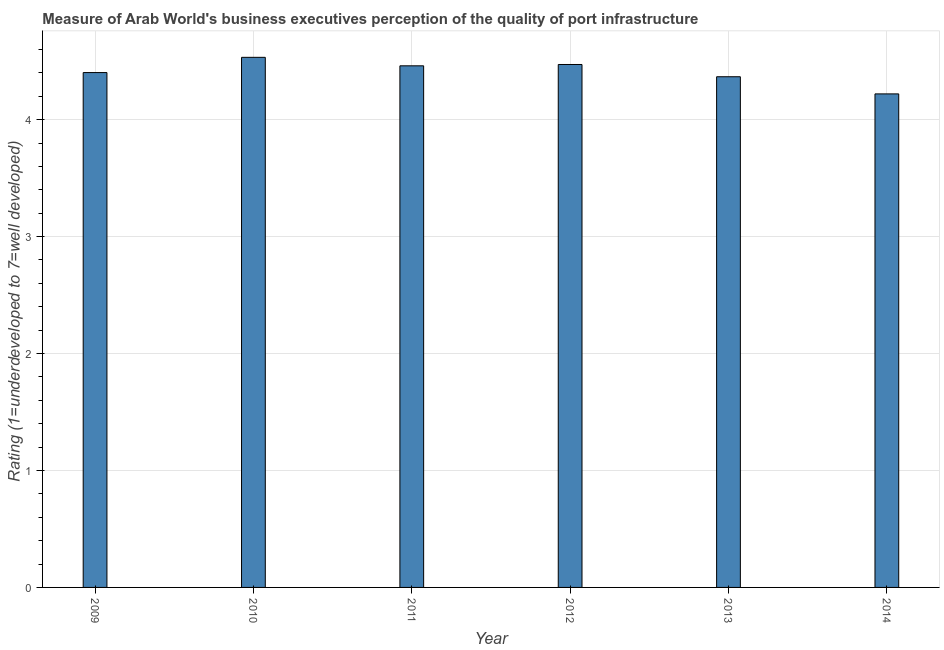Does the graph contain grids?
Offer a terse response. Yes. What is the title of the graph?
Give a very brief answer. Measure of Arab World's business executives perception of the quality of port infrastructure. What is the label or title of the Y-axis?
Offer a terse response. Rating (1=underdeveloped to 7=well developed) . What is the rating measuring quality of port infrastructure in 2010?
Ensure brevity in your answer.  4.53. Across all years, what is the maximum rating measuring quality of port infrastructure?
Give a very brief answer. 4.53. Across all years, what is the minimum rating measuring quality of port infrastructure?
Offer a terse response. 4.22. What is the sum of the rating measuring quality of port infrastructure?
Offer a terse response. 26.45. What is the difference between the rating measuring quality of port infrastructure in 2013 and 2014?
Provide a short and direct response. 0.15. What is the average rating measuring quality of port infrastructure per year?
Provide a succinct answer. 4.41. What is the median rating measuring quality of port infrastructure?
Offer a very short reply. 4.43. In how many years, is the rating measuring quality of port infrastructure greater than 0.8 ?
Give a very brief answer. 6. Is the difference between the rating measuring quality of port infrastructure in 2012 and 2014 greater than the difference between any two years?
Keep it short and to the point. No. What is the difference between the highest and the second highest rating measuring quality of port infrastructure?
Make the answer very short. 0.06. What is the difference between the highest and the lowest rating measuring quality of port infrastructure?
Your answer should be very brief. 0.31. In how many years, is the rating measuring quality of port infrastructure greater than the average rating measuring quality of port infrastructure taken over all years?
Offer a very short reply. 3. How many bars are there?
Offer a very short reply. 6. How many years are there in the graph?
Give a very brief answer. 6. Are the values on the major ticks of Y-axis written in scientific E-notation?
Give a very brief answer. No. What is the Rating (1=underdeveloped to 7=well developed)  of 2009?
Your answer should be compact. 4.4. What is the Rating (1=underdeveloped to 7=well developed)  in 2010?
Your answer should be very brief. 4.53. What is the Rating (1=underdeveloped to 7=well developed)  of 2011?
Your response must be concise. 4.46. What is the Rating (1=underdeveloped to 7=well developed)  of 2012?
Your answer should be very brief. 4.47. What is the Rating (1=underdeveloped to 7=well developed)  in 2013?
Your response must be concise. 4.37. What is the Rating (1=underdeveloped to 7=well developed)  in 2014?
Give a very brief answer. 4.22. What is the difference between the Rating (1=underdeveloped to 7=well developed)  in 2009 and 2010?
Make the answer very short. -0.13. What is the difference between the Rating (1=underdeveloped to 7=well developed)  in 2009 and 2011?
Provide a short and direct response. -0.06. What is the difference between the Rating (1=underdeveloped to 7=well developed)  in 2009 and 2012?
Your response must be concise. -0.07. What is the difference between the Rating (1=underdeveloped to 7=well developed)  in 2009 and 2013?
Your response must be concise. 0.04. What is the difference between the Rating (1=underdeveloped to 7=well developed)  in 2009 and 2014?
Provide a short and direct response. 0.18. What is the difference between the Rating (1=underdeveloped to 7=well developed)  in 2010 and 2011?
Make the answer very short. 0.07. What is the difference between the Rating (1=underdeveloped to 7=well developed)  in 2010 and 2012?
Ensure brevity in your answer.  0.06. What is the difference between the Rating (1=underdeveloped to 7=well developed)  in 2010 and 2013?
Your answer should be very brief. 0.17. What is the difference between the Rating (1=underdeveloped to 7=well developed)  in 2010 and 2014?
Provide a succinct answer. 0.31. What is the difference between the Rating (1=underdeveloped to 7=well developed)  in 2011 and 2012?
Offer a very short reply. -0.01. What is the difference between the Rating (1=underdeveloped to 7=well developed)  in 2011 and 2013?
Provide a short and direct response. 0.09. What is the difference between the Rating (1=underdeveloped to 7=well developed)  in 2011 and 2014?
Provide a short and direct response. 0.24. What is the difference between the Rating (1=underdeveloped to 7=well developed)  in 2012 and 2013?
Give a very brief answer. 0.1. What is the difference between the Rating (1=underdeveloped to 7=well developed)  in 2012 and 2014?
Offer a terse response. 0.25. What is the difference between the Rating (1=underdeveloped to 7=well developed)  in 2013 and 2014?
Your answer should be very brief. 0.15. What is the ratio of the Rating (1=underdeveloped to 7=well developed)  in 2009 to that in 2010?
Your response must be concise. 0.97. What is the ratio of the Rating (1=underdeveloped to 7=well developed)  in 2009 to that in 2011?
Offer a terse response. 0.99. What is the ratio of the Rating (1=underdeveloped to 7=well developed)  in 2009 to that in 2012?
Give a very brief answer. 0.98. What is the ratio of the Rating (1=underdeveloped to 7=well developed)  in 2009 to that in 2014?
Offer a very short reply. 1.04. What is the ratio of the Rating (1=underdeveloped to 7=well developed)  in 2010 to that in 2011?
Offer a very short reply. 1.02. What is the ratio of the Rating (1=underdeveloped to 7=well developed)  in 2010 to that in 2012?
Give a very brief answer. 1.01. What is the ratio of the Rating (1=underdeveloped to 7=well developed)  in 2010 to that in 2013?
Give a very brief answer. 1.04. What is the ratio of the Rating (1=underdeveloped to 7=well developed)  in 2010 to that in 2014?
Offer a very short reply. 1.07. What is the ratio of the Rating (1=underdeveloped to 7=well developed)  in 2011 to that in 2013?
Offer a terse response. 1.02. What is the ratio of the Rating (1=underdeveloped to 7=well developed)  in 2011 to that in 2014?
Provide a short and direct response. 1.06. What is the ratio of the Rating (1=underdeveloped to 7=well developed)  in 2012 to that in 2014?
Your answer should be very brief. 1.06. What is the ratio of the Rating (1=underdeveloped to 7=well developed)  in 2013 to that in 2014?
Your response must be concise. 1.03. 